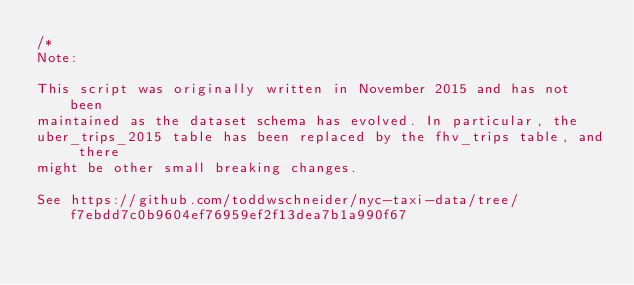<code> <loc_0><loc_0><loc_500><loc_500><_SQL_>/*
Note:

This script was originally written in November 2015 and has not been
maintained as the dataset schema has evolved. In particular, the
uber_trips_2015 table has been replaced by the fhv_trips table, and there
might be other small breaking changes.

See https://github.com/toddwschneider/nyc-taxi-data/tree/f7ebdd7c0b9604ef76959ef2f13dea7b1a990f67</code> 